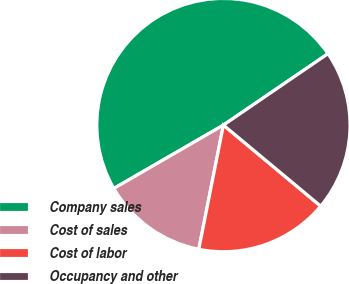Convert chart to OTSL. <chart><loc_0><loc_0><loc_500><loc_500><pie_chart><fcel>Company sales<fcel>Cost of sales<fcel>Cost of labor<fcel>Occupancy and other<nl><fcel>48.81%<fcel>13.54%<fcel>17.06%<fcel>20.59%<nl></chart> 